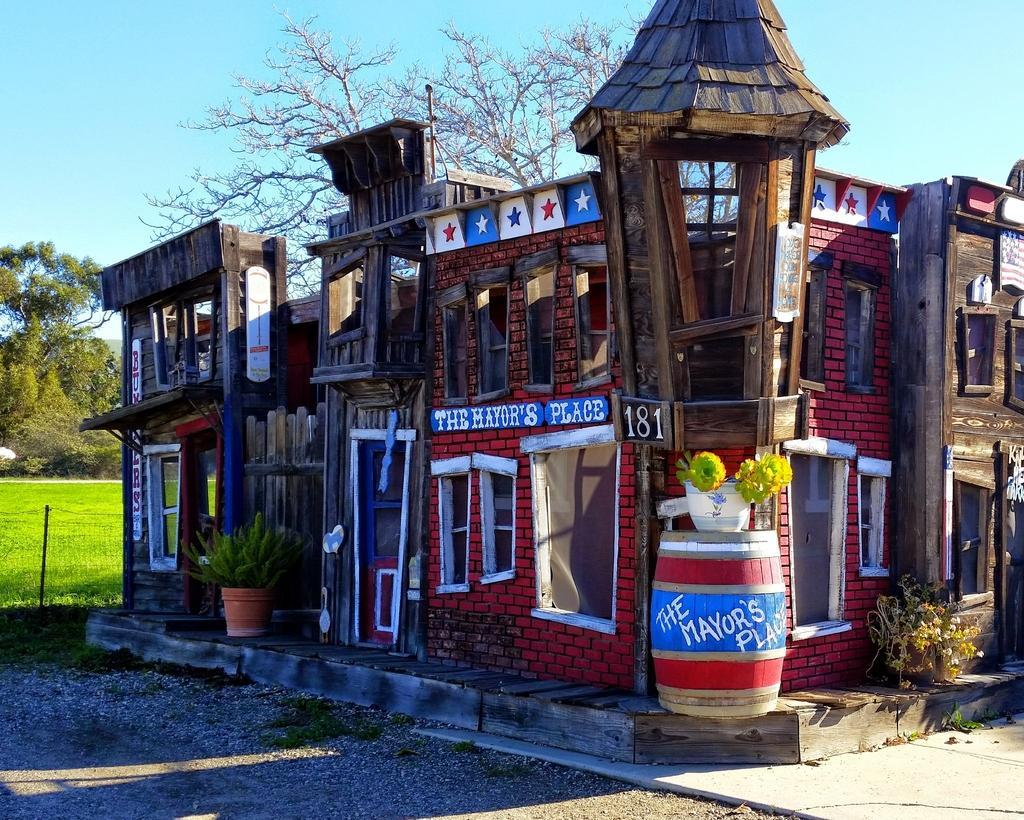Can you describe this image briefly? In this image I can see few buildings, glass windows, few plants and trees in green color and the sky is in blue color. 